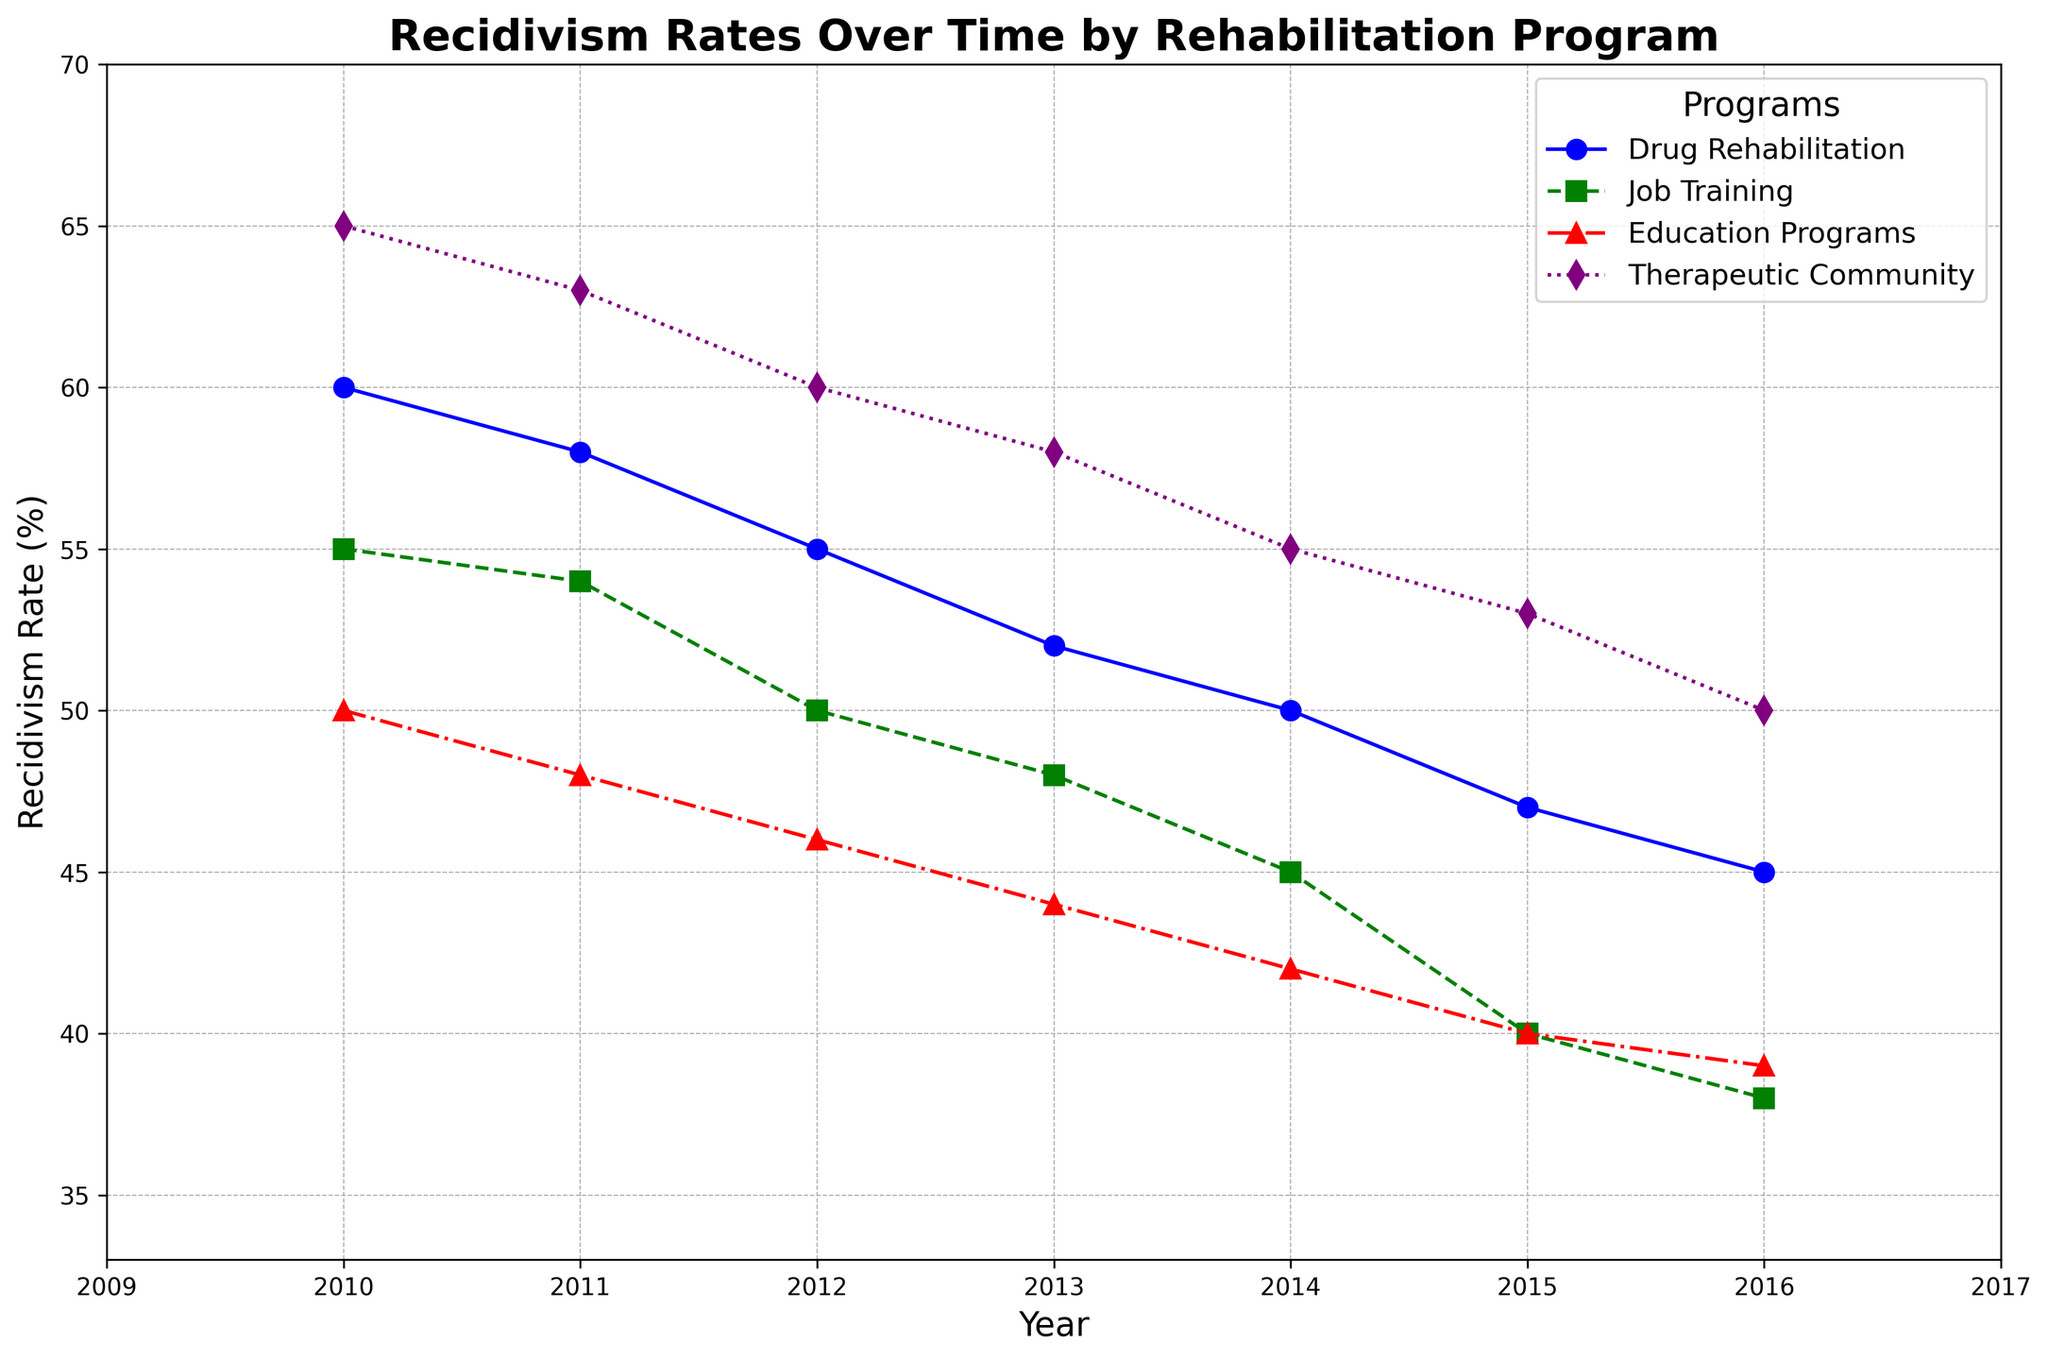Which rehabilitation program shows the greatest decrease in recidivism rate from 2010 to 2016? To determine which rehabilitation program has the greatest decrease, subtract the recidivism rate in 2016 from the rate in 2010 for each program. Drug Rehabilitation decreases from 60% to 45% (a reduction of 15%), Job Training from 55% to 38% (a reduction of 17%), Education Programs from 50% to 39% (a reduction of 11%), and Therapeutic Community from 65% to 50% (a reduction of 15%). Job Training shows the greatest reduction.
Answer: Job Training In 2013, which program had the highest recidivism rate? Compare the recidivism rates of all the programs in the year 2013: Drug Rehabilitation (52%), Job Training (48%), Education Programs (44%), and Therapeutic Community (58%). Therapeutic Community has the highest rate.
Answer: Therapeutic Community What is the average recidivism rate for Drug Rehabilitation over the period 2010-2016? Sum all annual recidivism rates for Drug Rehabilitation from 2010 to 2016 and divide by the number of years: (60 + 58 + 55 + 52 + 50 + 47 + 45) / 7 = 367 / 7 = 52.43.
Answer: 52.43% Which program had consistently lower recidivism rates than Drug Rehabilitation from 2010 to 2016? Check the recidivism rates of other programs for each year and compare them with Drug Rehabilitation. Job Training (lower in 2010, 2011, 2012, 2013, 2014, 2015, 2016) and Education Programs (lower in 2010, 2011, 2012, 2013, 2014, 2015, 2016) consistently had lower rates. Therapeutic Community did not because it had higher rates in all years.
Answer: Job Training and Education Programs Did any program experience an increase in recidivism rates during the period? Review the graph to see if any program's line trends upward at any point from 2010 to 2016. All the programs show a steady decline in recidivism rates, so none experienced an increase during this period.
Answer: No Between 2014 and 2015, which program saw the greatest decrease in recidivism rate? Calculate the difference in recidivism rates for each program between 2014 and 2015. Drug Rehabilitation decreased by 3% (50% to 47%), Job Training decreased by 5% (45% to 40%), Education Programs decreased by 2% (42% to 40%), and Therapeutic Community decreased by 2% (55% to 53%). Job Training saw the greatest decrease.
Answer: Job Training Which program had the lowest recidivism rate in 2016? Compare the recidivism rates of all the programs in 2016: Drug Rehabilitation (45%), Job Training (38%), Education Programs (39%), Therapeutic Community (50%). Job Training had the lowest rate.
Answer: Job Training 